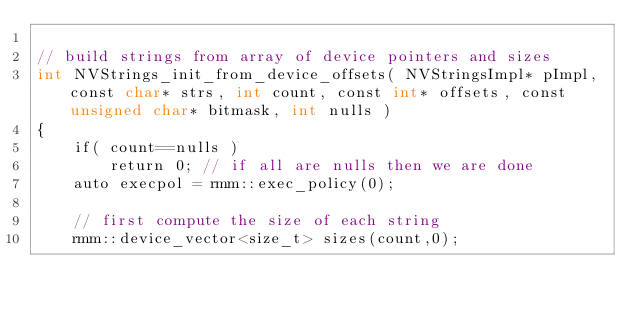<code> <loc_0><loc_0><loc_500><loc_500><_Cuda_>
// build strings from array of device pointers and sizes
int NVStrings_init_from_device_offsets( NVStringsImpl* pImpl, const char* strs, int count, const int* offsets, const unsigned char* bitmask, int nulls )
{
    if( count==nulls )
        return 0; // if all are nulls then we are done
    auto execpol = rmm::exec_policy(0);

    // first compute the size of each string
    rmm::device_vector<size_t> sizes(count,0);</code> 